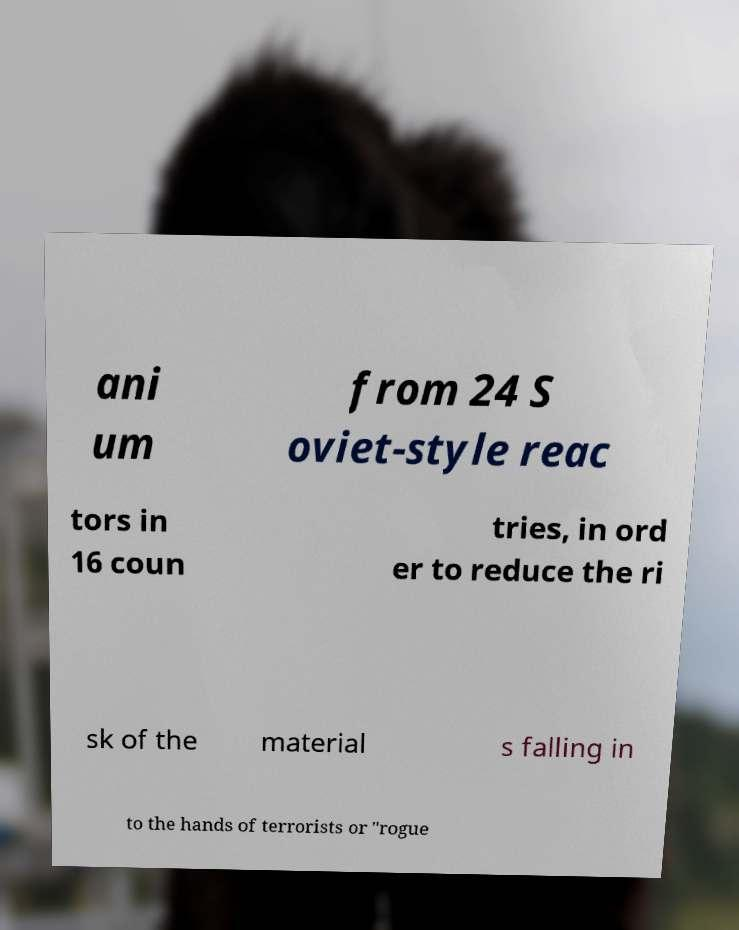Could you assist in decoding the text presented in this image and type it out clearly? ani um from 24 S oviet-style reac tors in 16 coun tries, in ord er to reduce the ri sk of the material s falling in to the hands of terrorists or "rogue 